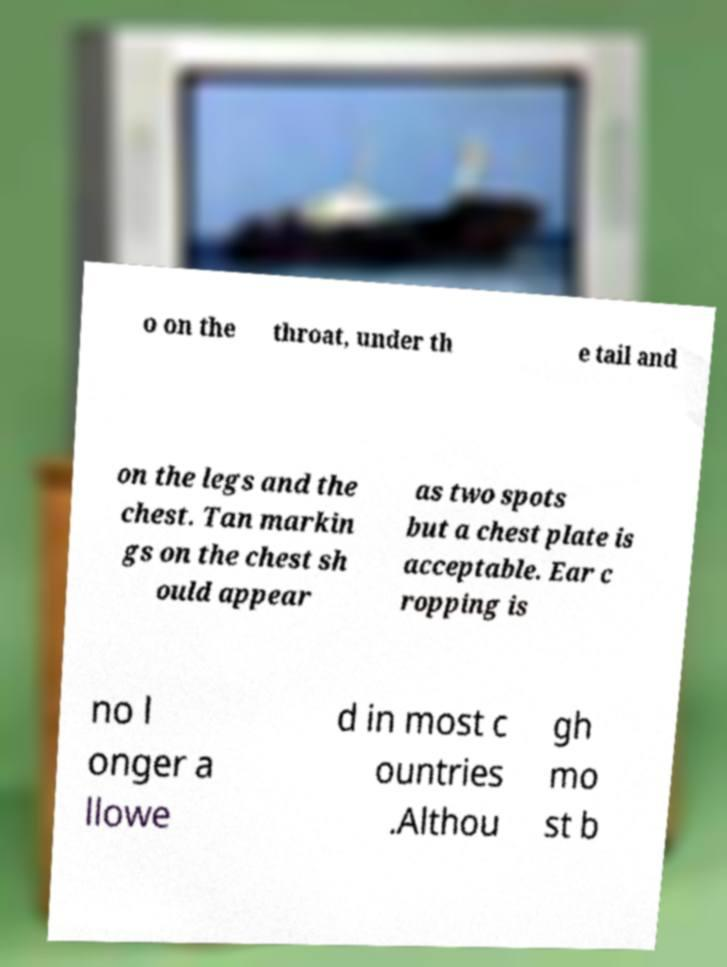What messages or text are displayed in this image? I need them in a readable, typed format. o on the throat, under th e tail and on the legs and the chest. Tan markin gs on the chest sh ould appear as two spots but a chest plate is acceptable. Ear c ropping is no l onger a llowe d in most c ountries .Althou gh mo st b 